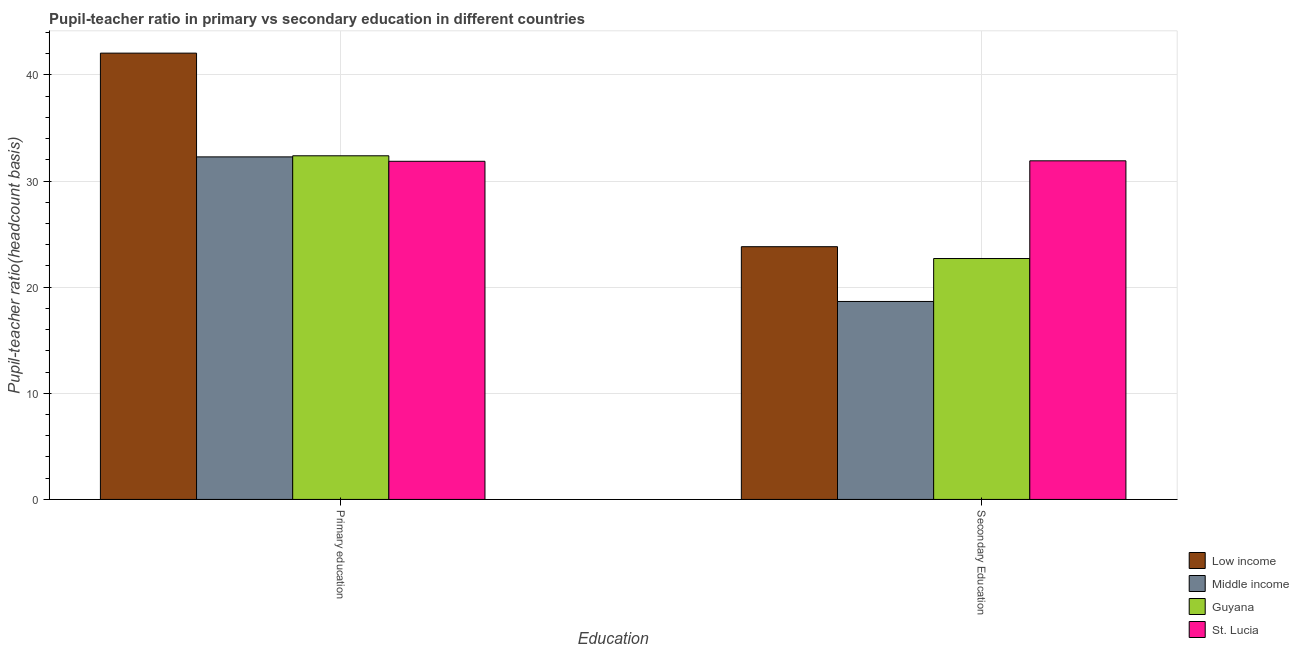How many bars are there on the 1st tick from the left?
Keep it short and to the point. 4. How many bars are there on the 2nd tick from the right?
Offer a terse response. 4. What is the label of the 2nd group of bars from the left?
Your answer should be very brief. Secondary Education. What is the pupil-teacher ratio in primary education in Guyana?
Your answer should be compact. 32.38. Across all countries, what is the maximum pupil-teacher ratio in primary education?
Provide a short and direct response. 42.05. Across all countries, what is the minimum pupil teacher ratio on secondary education?
Provide a short and direct response. 18.66. In which country was the pupil-teacher ratio in primary education minimum?
Your answer should be very brief. St. Lucia. What is the total pupil teacher ratio on secondary education in the graph?
Ensure brevity in your answer.  97.08. What is the difference between the pupil-teacher ratio in primary education in Low income and that in St. Lucia?
Give a very brief answer. 10.19. What is the difference between the pupil-teacher ratio in primary education in Middle income and the pupil teacher ratio on secondary education in St. Lucia?
Offer a terse response. 0.37. What is the average pupil-teacher ratio in primary education per country?
Your response must be concise. 34.64. What is the difference between the pupil-teacher ratio in primary education and pupil teacher ratio on secondary education in St. Lucia?
Your answer should be very brief. -0.05. What is the ratio of the pupil-teacher ratio in primary education in St. Lucia to that in Guyana?
Your answer should be compact. 0.98. What does the 4th bar from the left in Primary education represents?
Your response must be concise. St. Lucia. What does the 1st bar from the right in Primary education represents?
Give a very brief answer. St. Lucia. How many bars are there?
Give a very brief answer. 8. Are the values on the major ticks of Y-axis written in scientific E-notation?
Offer a terse response. No. Does the graph contain grids?
Offer a terse response. Yes. Where does the legend appear in the graph?
Make the answer very short. Bottom right. How many legend labels are there?
Your answer should be very brief. 4. How are the legend labels stacked?
Ensure brevity in your answer.  Vertical. What is the title of the graph?
Offer a terse response. Pupil-teacher ratio in primary vs secondary education in different countries. Does "Nigeria" appear as one of the legend labels in the graph?
Your answer should be very brief. No. What is the label or title of the X-axis?
Provide a short and direct response. Education. What is the label or title of the Y-axis?
Your answer should be compact. Pupil-teacher ratio(headcount basis). What is the Pupil-teacher ratio(headcount basis) of Low income in Primary education?
Give a very brief answer. 42.05. What is the Pupil-teacher ratio(headcount basis) in Middle income in Primary education?
Your answer should be very brief. 32.28. What is the Pupil-teacher ratio(headcount basis) of Guyana in Primary education?
Offer a very short reply. 32.38. What is the Pupil-teacher ratio(headcount basis) of St. Lucia in Primary education?
Make the answer very short. 31.86. What is the Pupil-teacher ratio(headcount basis) in Low income in Secondary Education?
Give a very brief answer. 23.82. What is the Pupil-teacher ratio(headcount basis) in Middle income in Secondary Education?
Your answer should be very brief. 18.66. What is the Pupil-teacher ratio(headcount basis) in Guyana in Secondary Education?
Your answer should be compact. 22.7. What is the Pupil-teacher ratio(headcount basis) in St. Lucia in Secondary Education?
Provide a succinct answer. 31.91. Across all Education, what is the maximum Pupil-teacher ratio(headcount basis) of Low income?
Offer a very short reply. 42.05. Across all Education, what is the maximum Pupil-teacher ratio(headcount basis) of Middle income?
Offer a very short reply. 32.28. Across all Education, what is the maximum Pupil-teacher ratio(headcount basis) of Guyana?
Give a very brief answer. 32.38. Across all Education, what is the maximum Pupil-teacher ratio(headcount basis) in St. Lucia?
Ensure brevity in your answer.  31.91. Across all Education, what is the minimum Pupil-teacher ratio(headcount basis) in Low income?
Give a very brief answer. 23.82. Across all Education, what is the minimum Pupil-teacher ratio(headcount basis) in Middle income?
Your answer should be compact. 18.66. Across all Education, what is the minimum Pupil-teacher ratio(headcount basis) in Guyana?
Provide a short and direct response. 22.7. Across all Education, what is the minimum Pupil-teacher ratio(headcount basis) of St. Lucia?
Your answer should be compact. 31.86. What is the total Pupil-teacher ratio(headcount basis) of Low income in the graph?
Your answer should be compact. 65.87. What is the total Pupil-teacher ratio(headcount basis) in Middle income in the graph?
Provide a short and direct response. 50.93. What is the total Pupil-teacher ratio(headcount basis) of Guyana in the graph?
Give a very brief answer. 55.08. What is the total Pupil-teacher ratio(headcount basis) in St. Lucia in the graph?
Keep it short and to the point. 63.77. What is the difference between the Pupil-teacher ratio(headcount basis) in Low income in Primary education and that in Secondary Education?
Your response must be concise. 18.24. What is the difference between the Pupil-teacher ratio(headcount basis) in Middle income in Primary education and that in Secondary Education?
Provide a succinct answer. 13.62. What is the difference between the Pupil-teacher ratio(headcount basis) in Guyana in Primary education and that in Secondary Education?
Provide a succinct answer. 9.68. What is the difference between the Pupil-teacher ratio(headcount basis) of St. Lucia in Primary education and that in Secondary Education?
Your response must be concise. -0.05. What is the difference between the Pupil-teacher ratio(headcount basis) in Low income in Primary education and the Pupil-teacher ratio(headcount basis) in Middle income in Secondary Education?
Ensure brevity in your answer.  23.4. What is the difference between the Pupil-teacher ratio(headcount basis) of Low income in Primary education and the Pupil-teacher ratio(headcount basis) of Guyana in Secondary Education?
Offer a very short reply. 19.35. What is the difference between the Pupil-teacher ratio(headcount basis) of Low income in Primary education and the Pupil-teacher ratio(headcount basis) of St. Lucia in Secondary Education?
Keep it short and to the point. 10.15. What is the difference between the Pupil-teacher ratio(headcount basis) in Middle income in Primary education and the Pupil-teacher ratio(headcount basis) in Guyana in Secondary Education?
Provide a short and direct response. 9.58. What is the difference between the Pupil-teacher ratio(headcount basis) in Middle income in Primary education and the Pupil-teacher ratio(headcount basis) in St. Lucia in Secondary Education?
Offer a very short reply. 0.37. What is the difference between the Pupil-teacher ratio(headcount basis) of Guyana in Primary education and the Pupil-teacher ratio(headcount basis) of St. Lucia in Secondary Education?
Keep it short and to the point. 0.47. What is the average Pupil-teacher ratio(headcount basis) of Low income per Education?
Offer a terse response. 32.94. What is the average Pupil-teacher ratio(headcount basis) of Middle income per Education?
Ensure brevity in your answer.  25.47. What is the average Pupil-teacher ratio(headcount basis) of Guyana per Education?
Your response must be concise. 27.54. What is the average Pupil-teacher ratio(headcount basis) of St. Lucia per Education?
Provide a succinct answer. 31.89. What is the difference between the Pupil-teacher ratio(headcount basis) in Low income and Pupil-teacher ratio(headcount basis) in Middle income in Primary education?
Make the answer very short. 9.78. What is the difference between the Pupil-teacher ratio(headcount basis) in Low income and Pupil-teacher ratio(headcount basis) in Guyana in Primary education?
Offer a very short reply. 9.67. What is the difference between the Pupil-teacher ratio(headcount basis) in Low income and Pupil-teacher ratio(headcount basis) in St. Lucia in Primary education?
Provide a short and direct response. 10.19. What is the difference between the Pupil-teacher ratio(headcount basis) in Middle income and Pupil-teacher ratio(headcount basis) in Guyana in Primary education?
Ensure brevity in your answer.  -0.1. What is the difference between the Pupil-teacher ratio(headcount basis) in Middle income and Pupil-teacher ratio(headcount basis) in St. Lucia in Primary education?
Make the answer very short. 0.42. What is the difference between the Pupil-teacher ratio(headcount basis) of Guyana and Pupil-teacher ratio(headcount basis) of St. Lucia in Primary education?
Offer a terse response. 0.52. What is the difference between the Pupil-teacher ratio(headcount basis) in Low income and Pupil-teacher ratio(headcount basis) in Middle income in Secondary Education?
Make the answer very short. 5.16. What is the difference between the Pupil-teacher ratio(headcount basis) in Low income and Pupil-teacher ratio(headcount basis) in Guyana in Secondary Education?
Your answer should be compact. 1.11. What is the difference between the Pupil-teacher ratio(headcount basis) in Low income and Pupil-teacher ratio(headcount basis) in St. Lucia in Secondary Education?
Keep it short and to the point. -8.09. What is the difference between the Pupil-teacher ratio(headcount basis) of Middle income and Pupil-teacher ratio(headcount basis) of Guyana in Secondary Education?
Provide a short and direct response. -4.05. What is the difference between the Pupil-teacher ratio(headcount basis) in Middle income and Pupil-teacher ratio(headcount basis) in St. Lucia in Secondary Education?
Ensure brevity in your answer.  -13.25. What is the difference between the Pupil-teacher ratio(headcount basis) in Guyana and Pupil-teacher ratio(headcount basis) in St. Lucia in Secondary Education?
Your answer should be compact. -9.21. What is the ratio of the Pupil-teacher ratio(headcount basis) of Low income in Primary education to that in Secondary Education?
Your answer should be compact. 1.77. What is the ratio of the Pupil-teacher ratio(headcount basis) in Middle income in Primary education to that in Secondary Education?
Give a very brief answer. 1.73. What is the ratio of the Pupil-teacher ratio(headcount basis) of Guyana in Primary education to that in Secondary Education?
Offer a very short reply. 1.43. What is the ratio of the Pupil-teacher ratio(headcount basis) of St. Lucia in Primary education to that in Secondary Education?
Give a very brief answer. 1. What is the difference between the highest and the second highest Pupil-teacher ratio(headcount basis) in Low income?
Offer a terse response. 18.24. What is the difference between the highest and the second highest Pupil-teacher ratio(headcount basis) of Middle income?
Give a very brief answer. 13.62. What is the difference between the highest and the second highest Pupil-teacher ratio(headcount basis) of Guyana?
Ensure brevity in your answer.  9.68. What is the difference between the highest and the second highest Pupil-teacher ratio(headcount basis) of St. Lucia?
Offer a very short reply. 0.05. What is the difference between the highest and the lowest Pupil-teacher ratio(headcount basis) in Low income?
Make the answer very short. 18.24. What is the difference between the highest and the lowest Pupil-teacher ratio(headcount basis) in Middle income?
Ensure brevity in your answer.  13.62. What is the difference between the highest and the lowest Pupil-teacher ratio(headcount basis) in Guyana?
Provide a short and direct response. 9.68. What is the difference between the highest and the lowest Pupil-teacher ratio(headcount basis) in St. Lucia?
Your answer should be very brief. 0.05. 